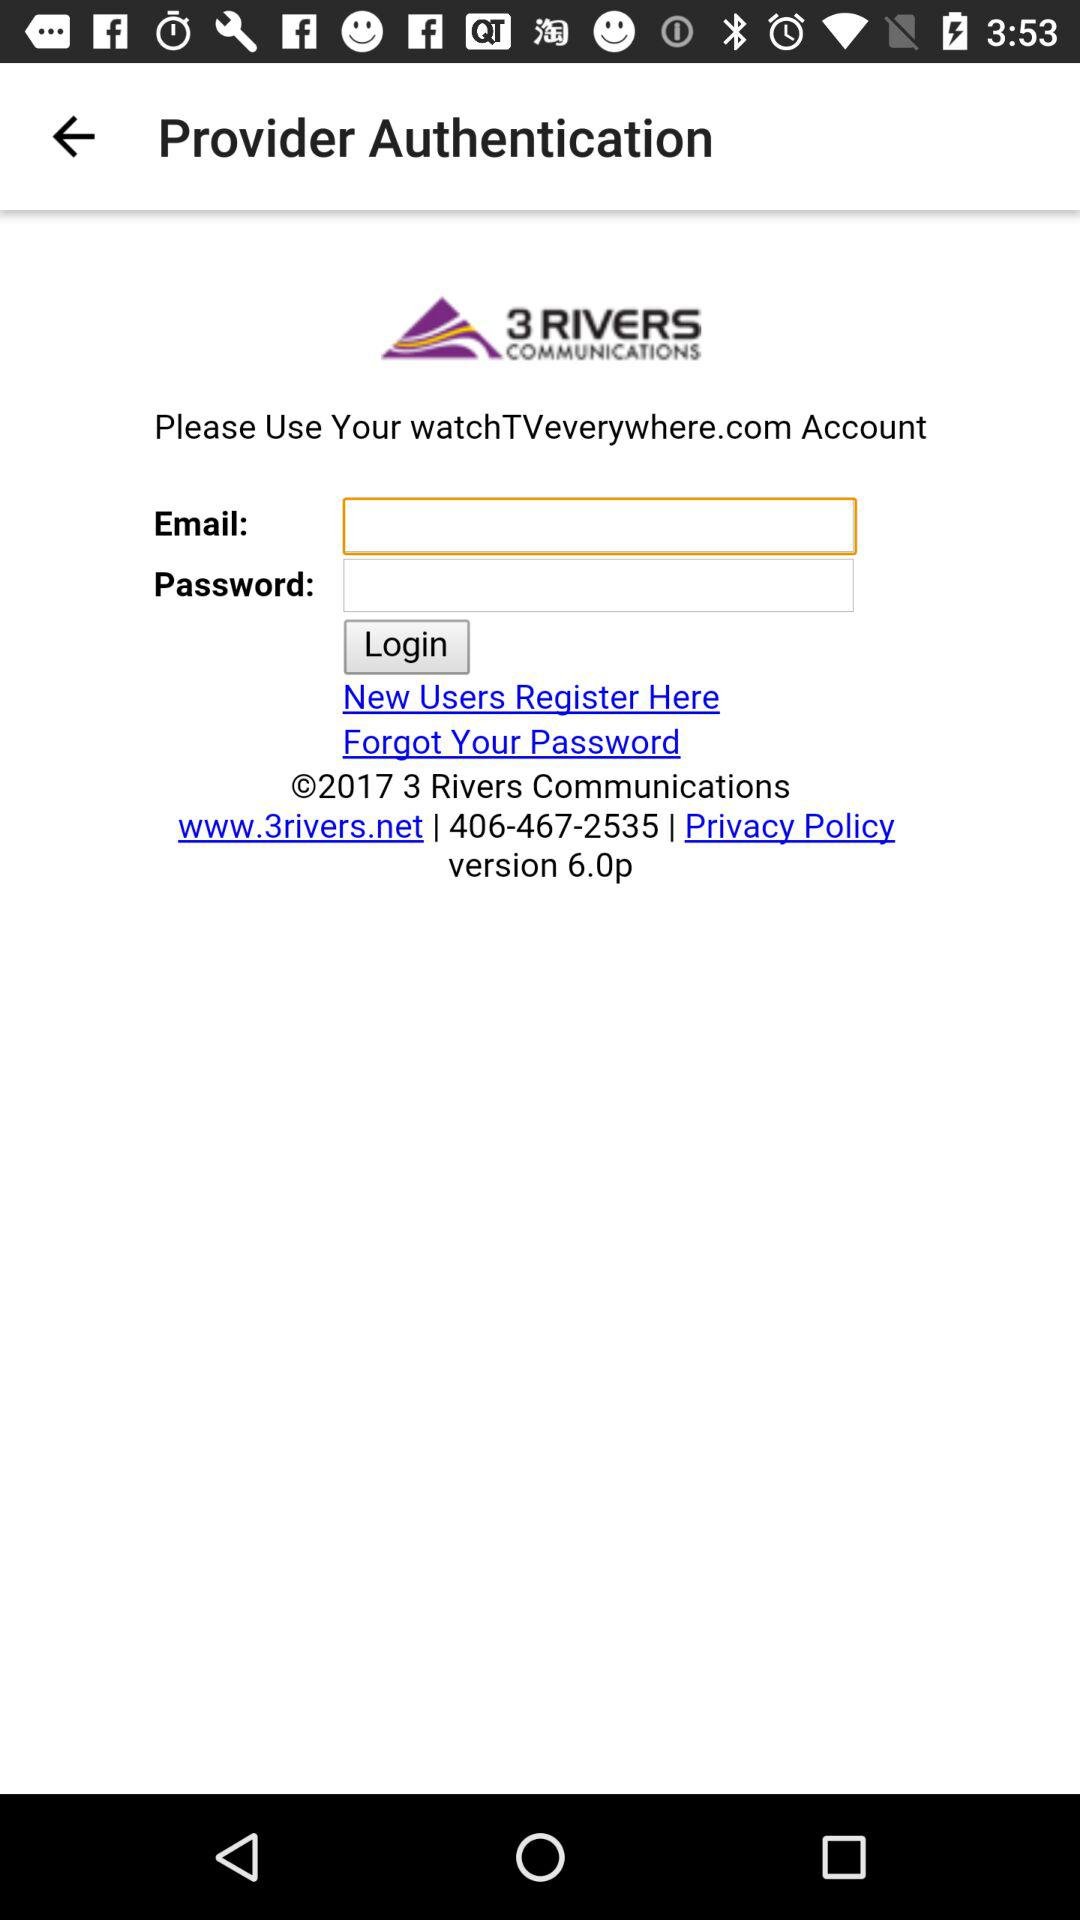What is the version number? The version number is 6.0p. 